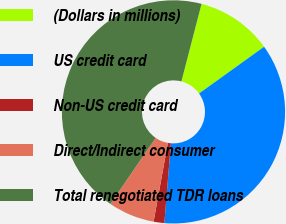<chart> <loc_0><loc_0><loc_500><loc_500><pie_chart><fcel>(Dollars in millions)<fcel>US credit card<fcel>Non-US credit card<fcel>Direct/Indirect consumer<fcel>Total renegotiated TDR loans<nl><fcel>11.04%<fcel>36.22%<fcel>1.55%<fcel>6.71%<fcel>44.48%<nl></chart> 